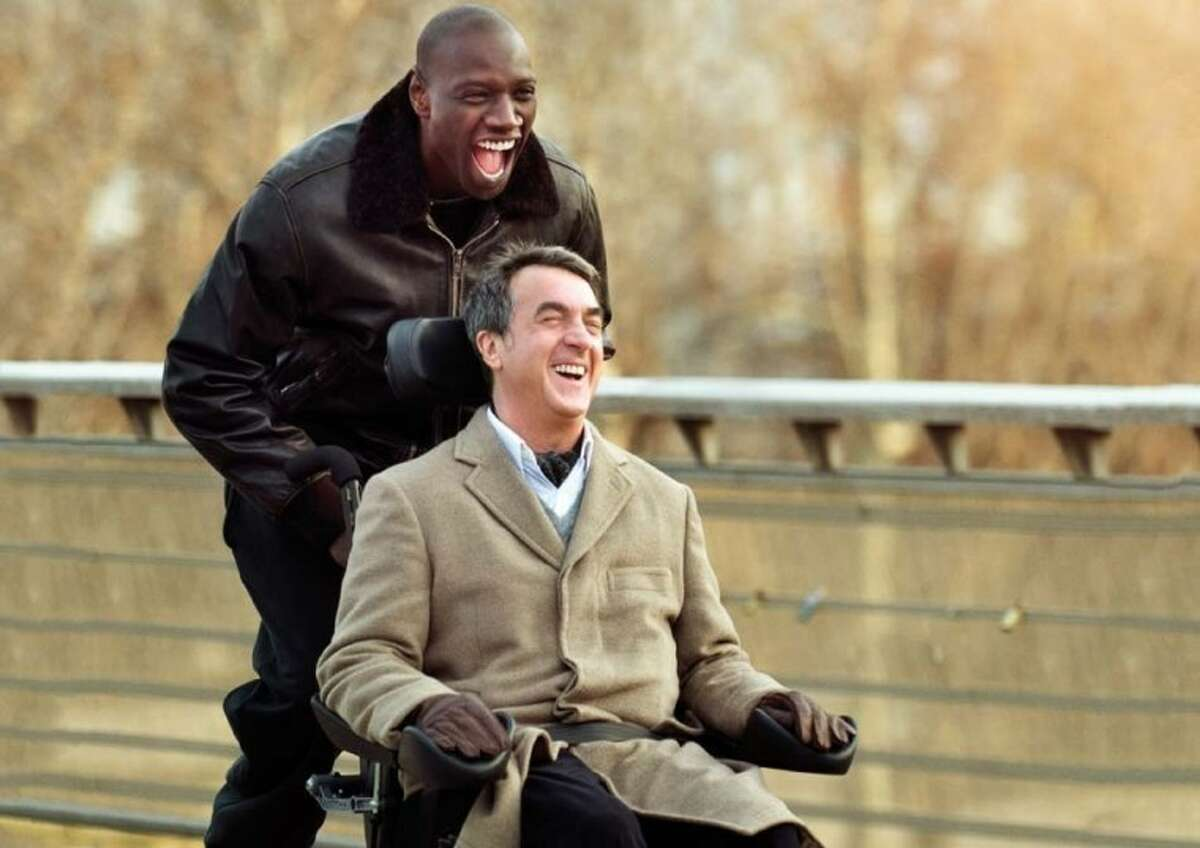Can you tell me more about the setting of this image? Certainly. The backdrop is slightly blurred, yet it provides enough detail to identify a natural setting, which could likely be a park or riverside walkway due to the presence of the trees and the bridge. This choice of location for the shared moment suggests an environment often associated with leisure and relaxation, further hinting that this instance of joy may have been captured during a break from the routines of daily life. How might the setting contribute to the overall mood of the image? Settings often play a subtle yet critical role in affecting and reflecting the moods of the subjects within them. In this image, the natural setting contributes a sense of tranquility and space. In addition, the open bridge implies a crossing or transition, which, coupled with the exuberance of the subjects, may symbolize moving forward in life with joy and overcoming obstacles with the support of companionship. 